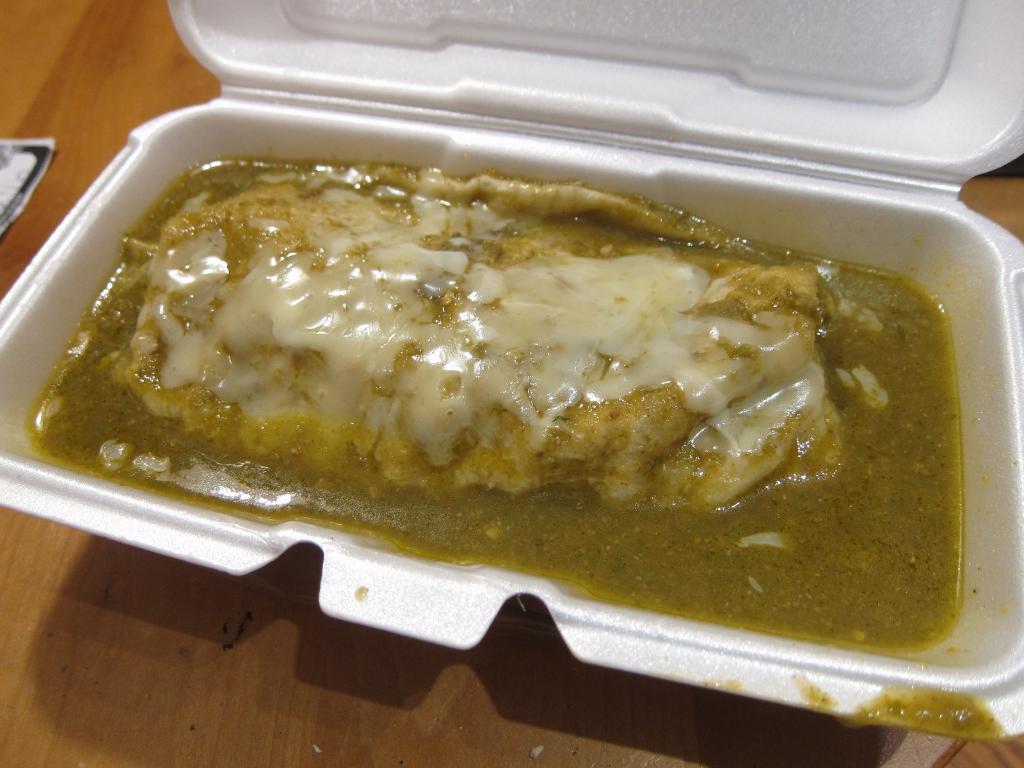In one or two sentences, can you explain what this image depicts? In the foreground of this image, there is food item in a cup like an object which is having a lid and it is on the wooden surface. On the left, there is an object. 